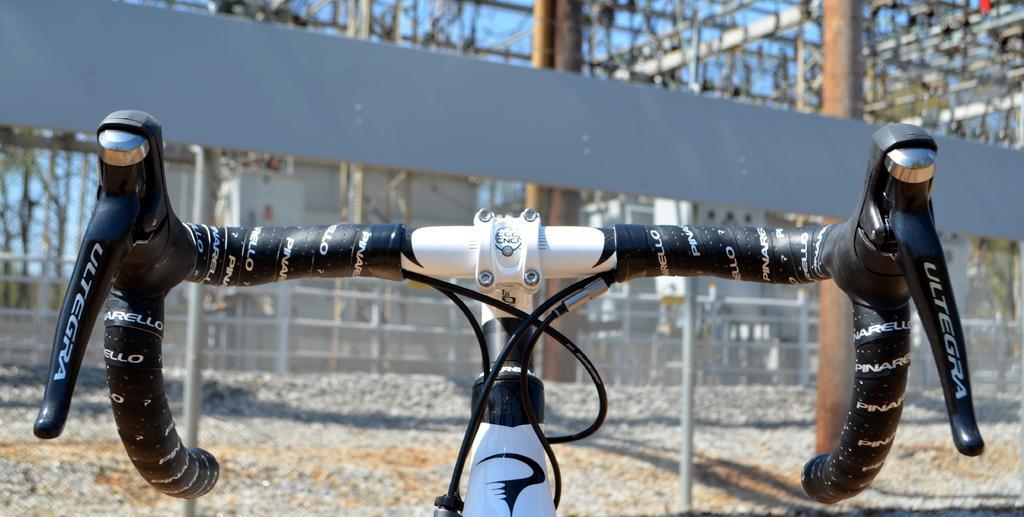Describe this image in one or two sentences. In this picture there is a bicycle handle in the front. Behind there is a fencing grill and some iron frames. 